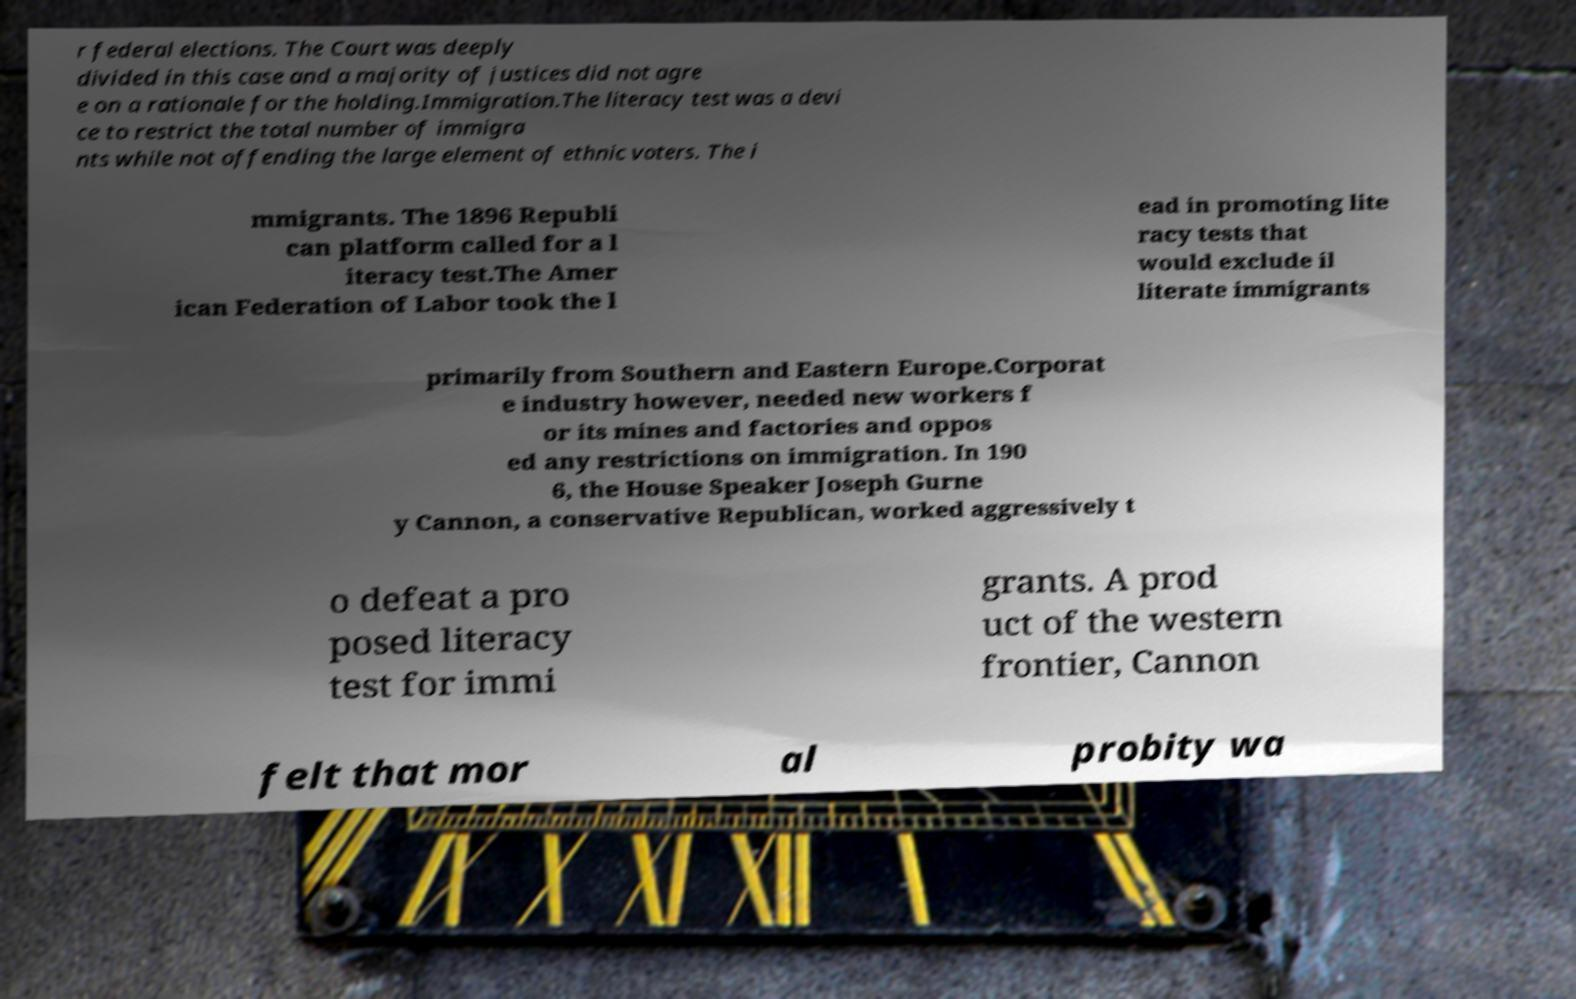For documentation purposes, I need the text within this image transcribed. Could you provide that? r federal elections. The Court was deeply divided in this case and a majority of justices did not agre e on a rationale for the holding.Immigration.The literacy test was a devi ce to restrict the total number of immigra nts while not offending the large element of ethnic voters. The i mmigrants. The 1896 Republi can platform called for a l iteracy test.The Amer ican Federation of Labor took the l ead in promoting lite racy tests that would exclude il literate immigrants primarily from Southern and Eastern Europe.Corporat e industry however, needed new workers f or its mines and factories and oppos ed any restrictions on immigration. In 190 6, the House Speaker Joseph Gurne y Cannon, a conservative Republican, worked aggressively t o defeat a pro posed literacy test for immi grants. A prod uct of the western frontier, Cannon felt that mor al probity wa 